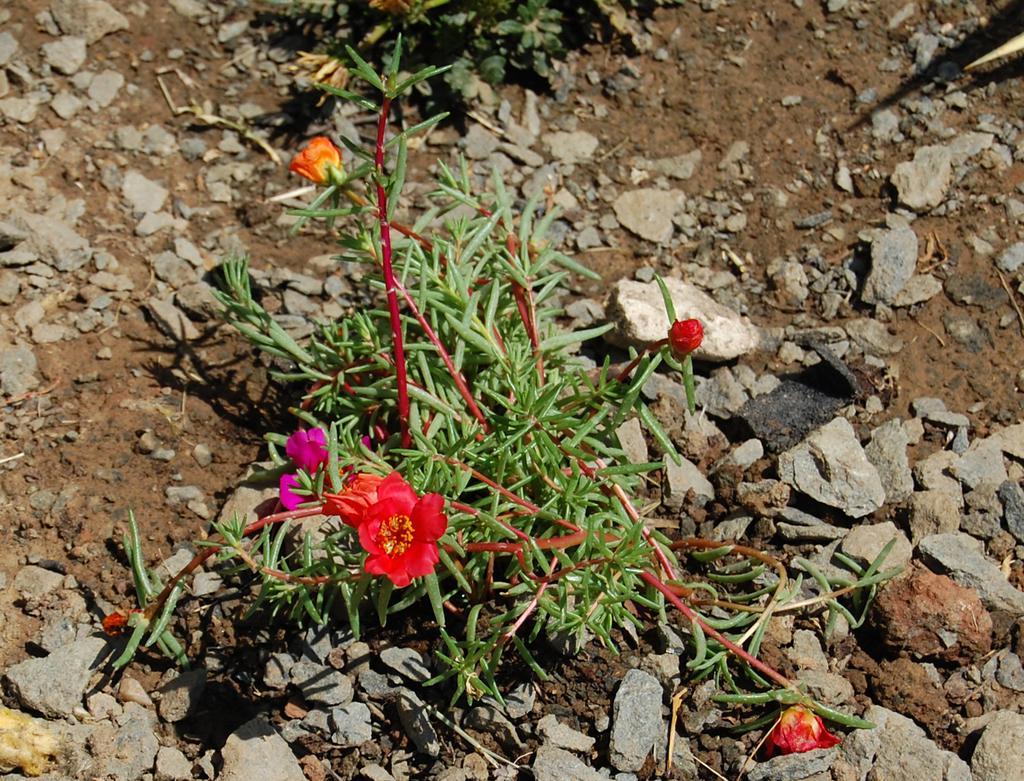Please provide a concise description of this image. This image consists of flowers in red and orange color. At the bottom, there is a small plant. And there are rocks on the ground. 